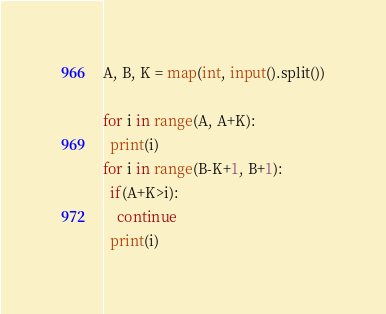<code> <loc_0><loc_0><loc_500><loc_500><_Python_>A, B, K = map(int, input().split())
 
for i in range(A, A+K):
  print(i)
for i in range(B-K+1, B+1):
  if(A+K>i):
    continue
  print(i)</code> 